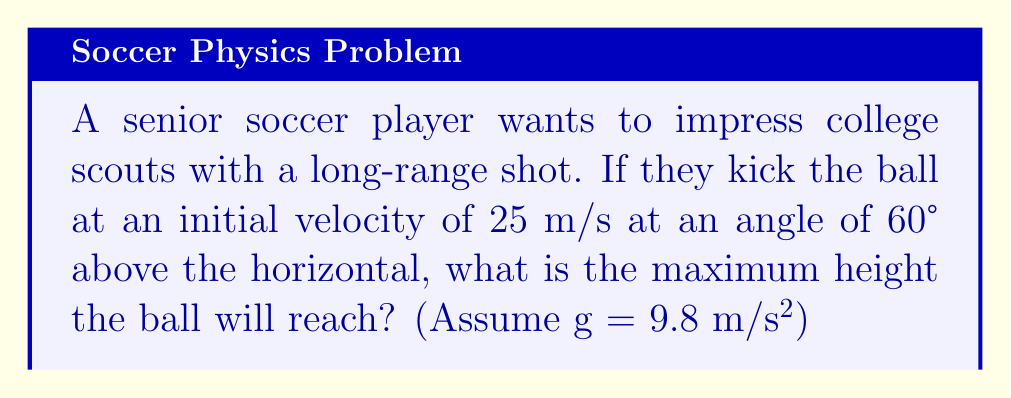Solve this math problem. Let's approach this step-by-step:

1) The maximum height of a projectile occurs when the vertical velocity becomes zero. We'll use the equation:

   $$h_{max} = \frac{(v_0 \sin \theta)^2}{2g}$$

   Where:
   $h_{max}$ is the maximum height
   $v_0$ is the initial velocity
   $\theta$ is the launch angle
   $g$ is the acceleration due to gravity

2) We're given:
   $v_0 = 25$ m/s
   $\theta = 60°$
   $g = 9.8$ m/s²

3) First, let's calculate $\sin 60°$:
   $$\sin 60° = \frac{\sqrt{3}}{2} \approx 0.866$$

4) Now, let's substitute these values into our equation:

   $$h_{max} = \frac{(25 \cdot 0.866)^2}{2 \cdot 9.8}$$

5) Simplify:
   $$h_{max} = \frac{(21.65)^2}{19.6} = \frac{468.72}{19.6}$$

6) Calculate the final result:
   $$h_{max} = 23.91$$ meters

Therefore, the ball will reach a maximum height of approximately 23.91 meters.
Answer: 23.91 m 